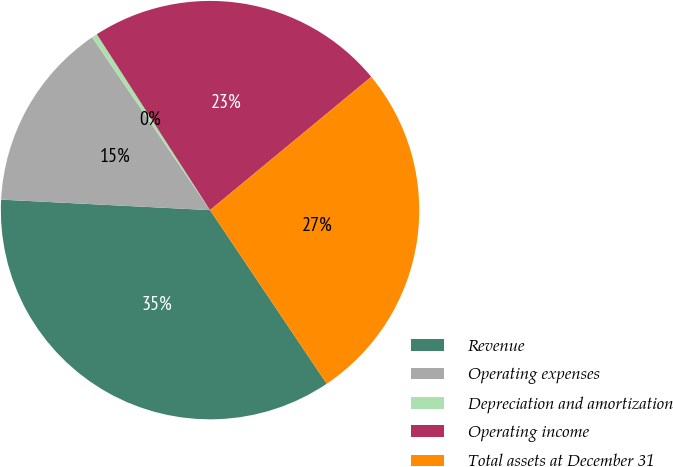Convert chart to OTSL. <chart><loc_0><loc_0><loc_500><loc_500><pie_chart><fcel>Revenue<fcel>Operating expenses<fcel>Depreciation and amortization<fcel>Operating income<fcel>Total assets at December 31<nl><fcel>35.22%<fcel>14.67%<fcel>0.43%<fcel>23.11%<fcel>26.58%<nl></chart> 